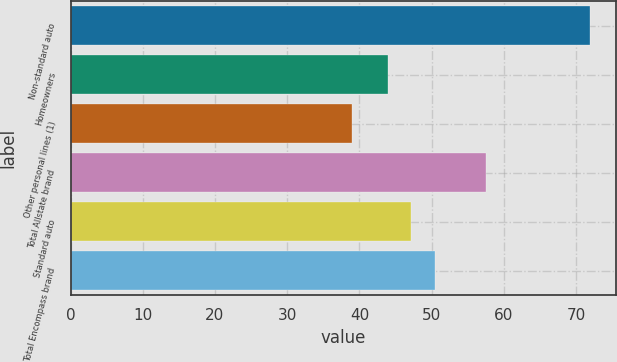<chart> <loc_0><loc_0><loc_500><loc_500><bar_chart><fcel>Non-standard auto<fcel>Homeowners<fcel>Other personal lines (1)<fcel>Total Allstate brand<fcel>Standard auto<fcel>Total Encompass brand<nl><fcel>71.9<fcel>43.9<fcel>39<fcel>57.6<fcel>47.19<fcel>50.48<nl></chart> 